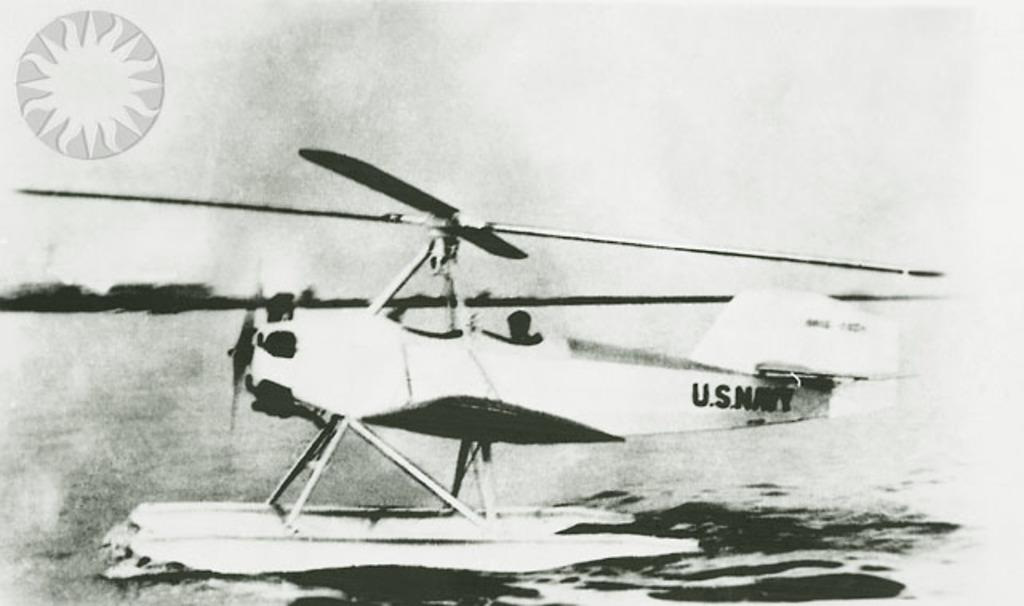<image>
Write a terse but informative summary of the picture. An airplane with the words U.S. Navy written on the tail 